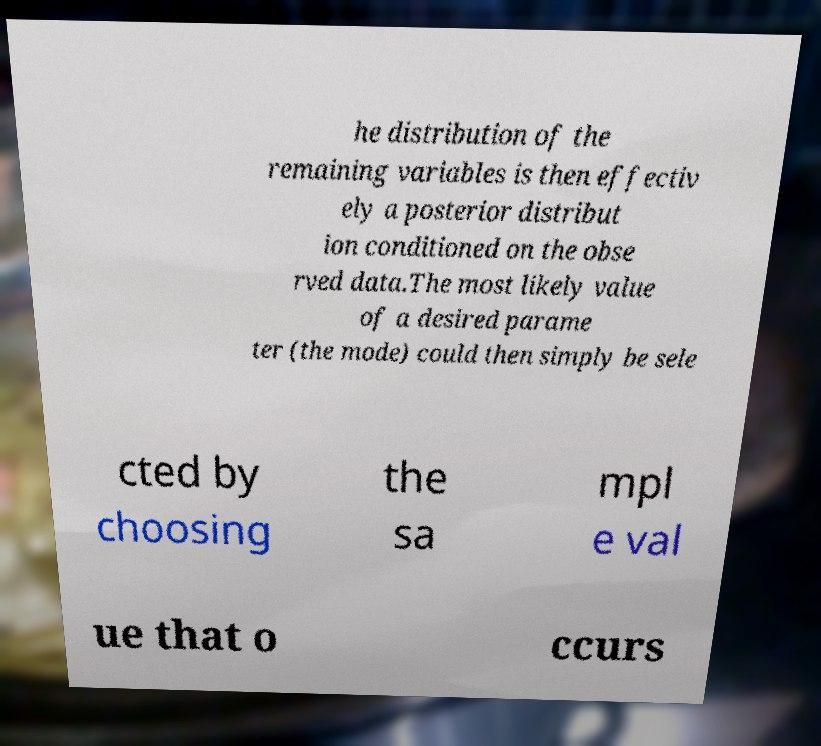What messages or text are displayed in this image? I need them in a readable, typed format. he distribution of the remaining variables is then effectiv ely a posterior distribut ion conditioned on the obse rved data.The most likely value of a desired parame ter (the mode) could then simply be sele cted by choosing the sa mpl e val ue that o ccurs 